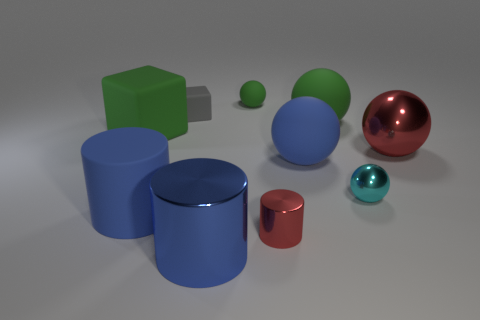Subtract all large blue spheres. How many spheres are left? 4 Subtract all cyan spheres. How many spheres are left? 4 Subtract all yellow spheres. Subtract all gray blocks. How many spheres are left? 5 Subtract all blocks. How many objects are left? 8 Add 4 big blue metal cylinders. How many big blue metal cylinders exist? 5 Subtract 0 red cubes. How many objects are left? 10 Subtract all green rubber balls. Subtract all matte objects. How many objects are left? 2 Add 8 small green rubber objects. How many small green rubber objects are left? 9 